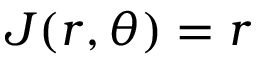<formula> <loc_0><loc_0><loc_500><loc_500>J ( r , \theta ) = r</formula> 